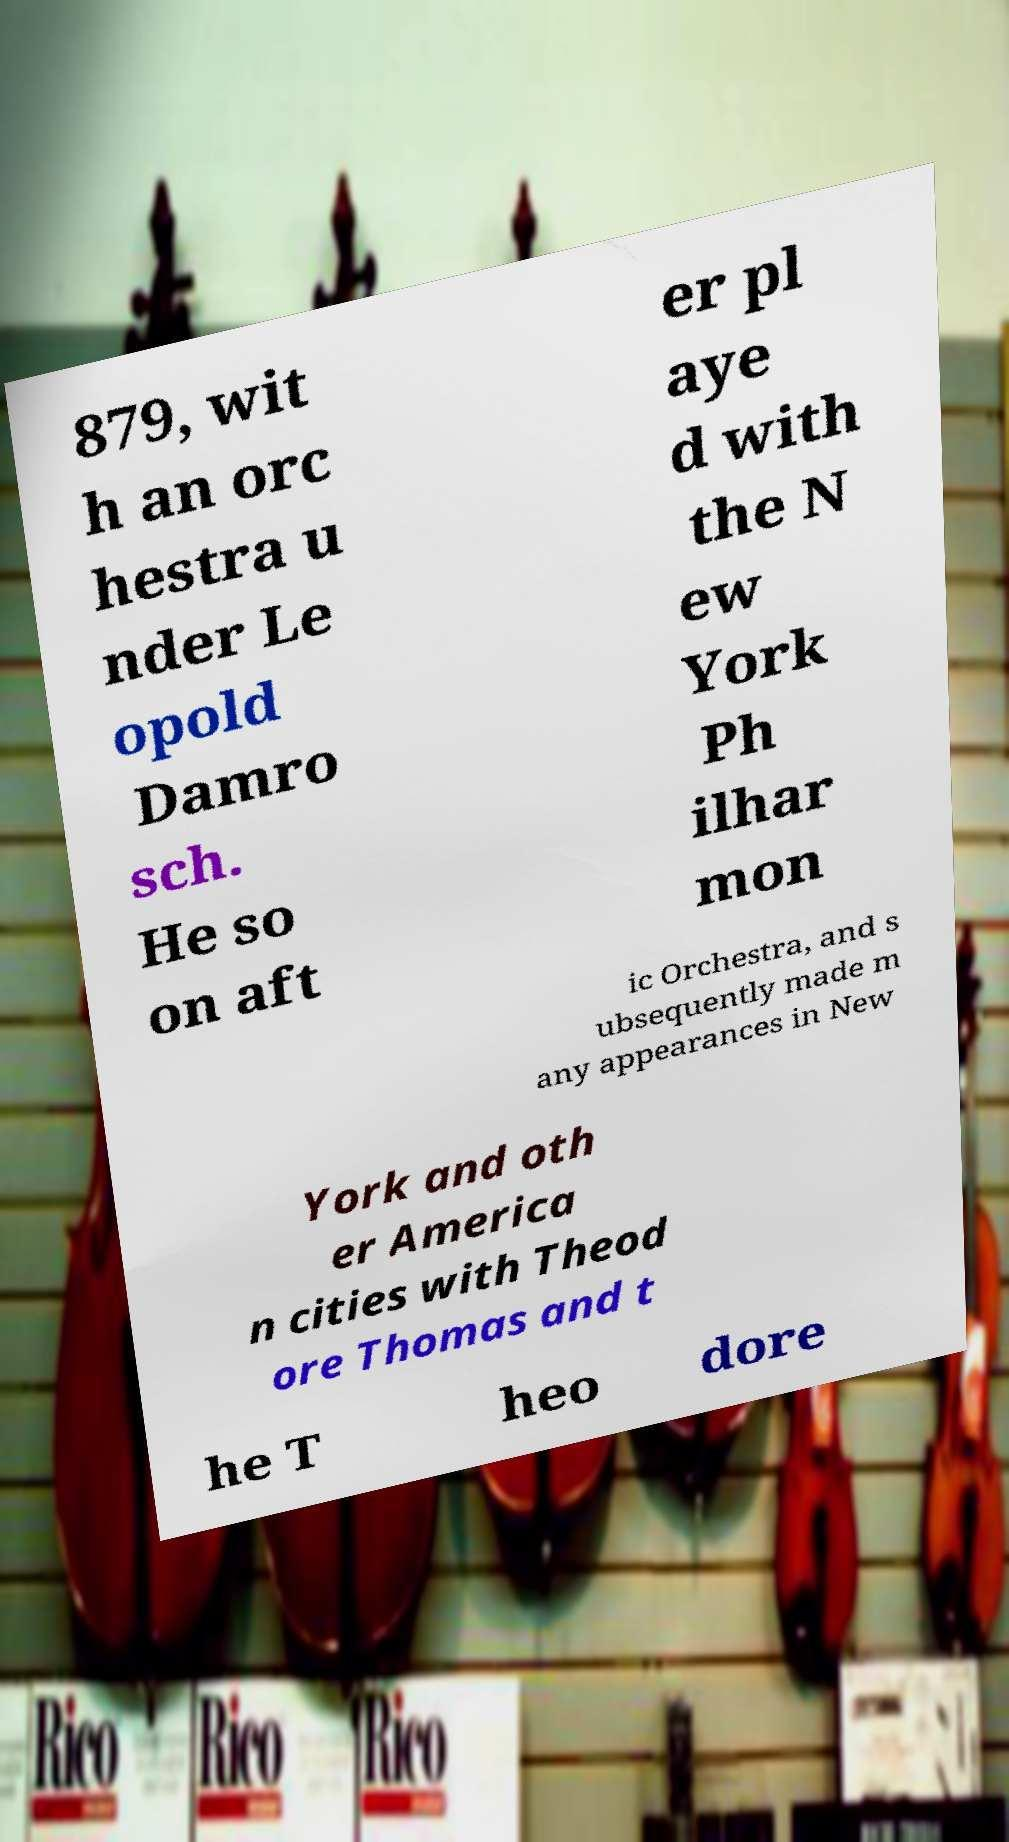I need the written content from this picture converted into text. Can you do that? 879, wit h an orc hestra u nder Le opold Damro sch. He so on aft er pl aye d with the N ew York Ph ilhar mon ic Orchestra, and s ubsequently made m any appearances in New York and oth er America n cities with Theod ore Thomas and t he T heo dore 